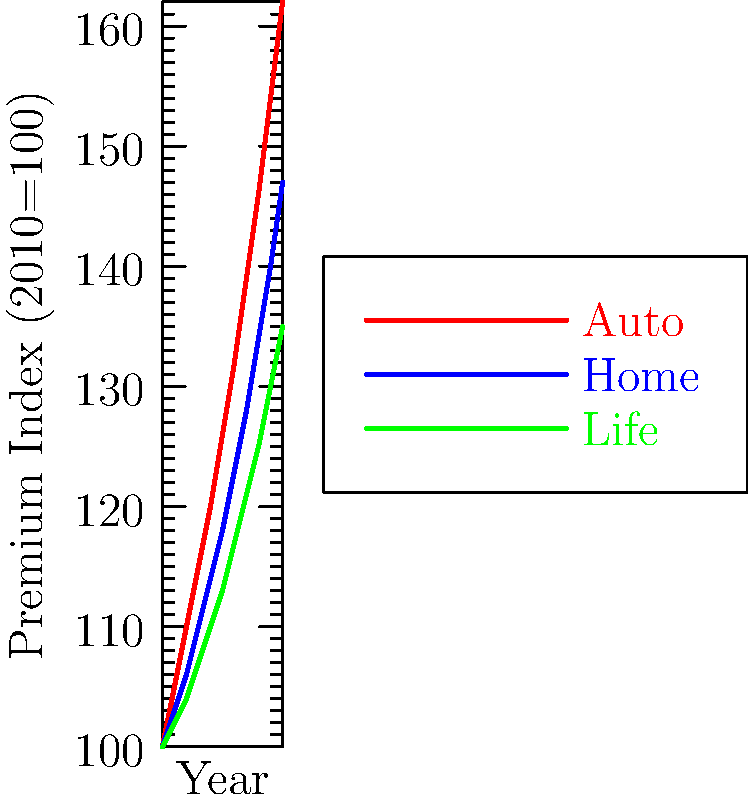Based on the time series analysis shown in the multiple line chart, which type of insurance premium is expected to have the highest increase by 2025 if the current trends continue? To determine which insurance premium is likely to have the highest increase by 2025, we need to analyze the trends for each type of insurance:

1. Auto Insurance (red line):
   - Started at 100 in 2010
   - Reached 162 in 2020
   - Growth rate: (162 - 100) / 10 years = 6.2% per year

2. Home Insurance (blue line):
   - Started at 100 in 2010
   - Reached 147 in 2020
   - Growth rate: (147 - 100) / 10 years = 4.7% per year

3. Life Insurance (green line):
   - Started at 100 in 2010
   - Reached 135 in 2020
   - Growth rate: (135 - 100) / 10 years = 3.5% per year

The auto insurance premium shows the steepest slope and the highest growth rate among the three types. If we extrapolate this trend to 2025:

Auto Insurance in 2025: $162 * (1 + 0.062)^5 = 218.5$

This increase is significantly higher than what we would expect for home and life insurance premiums based on their slower growth rates.

Therefore, if current trends continue, auto insurance premiums are expected to have the highest increase by 2025.
Answer: Auto insurance 